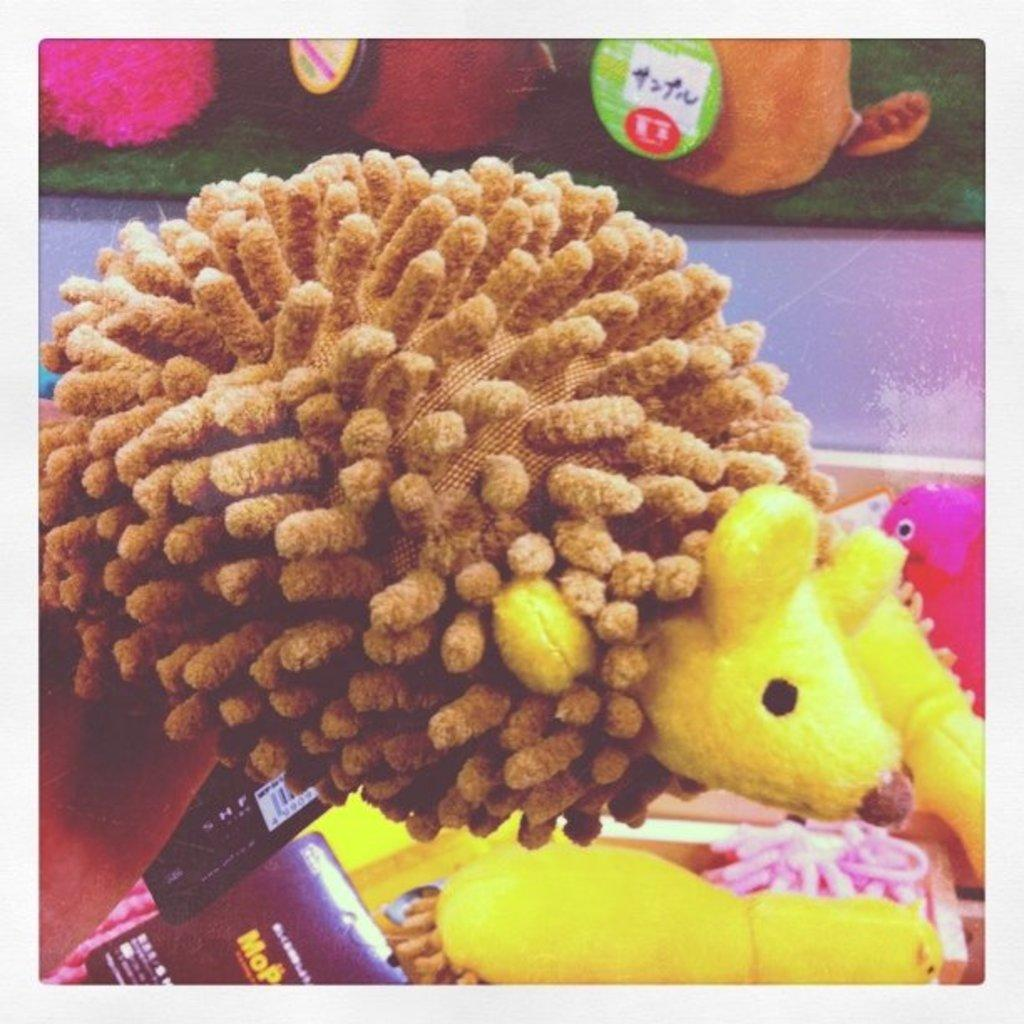What objects can be seen in the image? There are toys in the image. Are there any additional features on the toys? Yes, there are stickers on two of the toys. How does the table in the image contribute to the toys' burning process? There is no table present in the image, and the toys are not on fire or burning. 